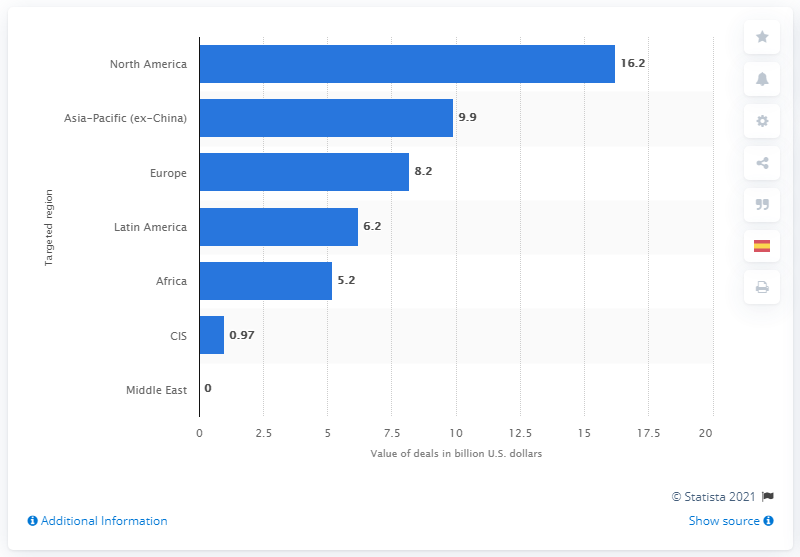Mention a couple of crucial points in this snapshot. The value of deals in the Asia-Pacific region in 2017 was 9.9 billion dollars. 